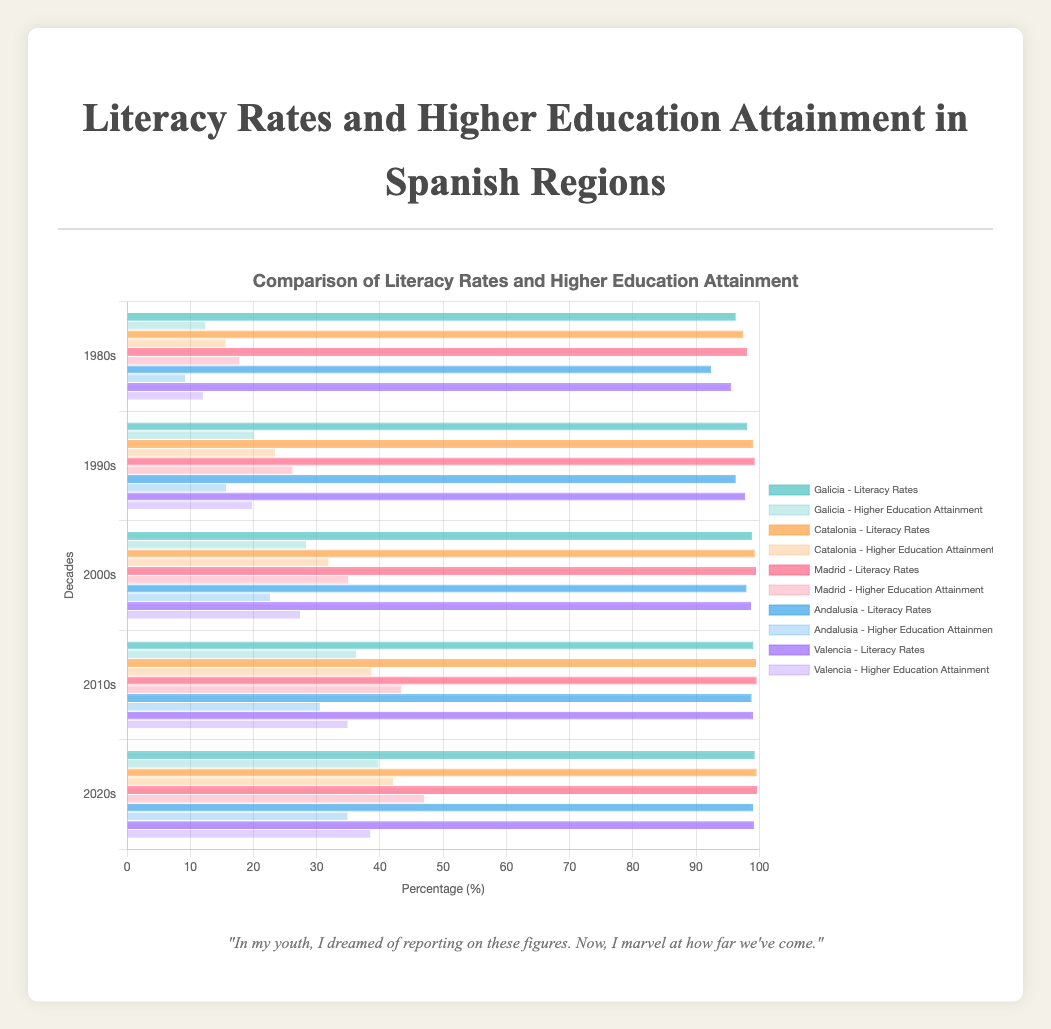Which region had the highest literacy rate in the 2020s? By observing the bar lengths for literacy rates in the 2020s, Madrid has the longest bar, indicating the highest literacy rate.
Answer: Madrid What is the difference in higher education attainment between Galicia and Madrid in the 2010s? To find the difference, subtract Galicia's higher education rate in the 2010s (36.2) from Madrid's (43.4). Thus, 43.4 - 36.2 = 7.2%.
Answer: 7.2% By how much did Galicia's literacy rate improve from the 1980s to the 2020s? Subtract the literacy rate of Galicia in the 1980s (96.3) from its rate in the 2020s (99.3). Thus, 99.3 - 96.3 = 3%.
Answer: 3% Which region showed the biggest increase in higher education attainment from the 1980s to the 2020s? Calculate the difference for each region: Galicia (39.8 - 12.4 = 27.4), Catalonia (42.1 - 15.6 = 26.5), Madrid (47.0 - 17.8 = 29.2), Andalusia (34.9 - 9.2 = 25.7), and Valencia (38.5 - 12.0 = 26.5). Madrid has the highest increase.
Answer: Madrid What was the average literacy rate for Galicia across all the decades? Add the literacy rates for Galicia across the decades and divide by the number of decades: (96.3 + 98.1 + 98.9 + 99.1 + 99.3) / 5 = 98.34%.
Answer: 98.34% Which decade had the lowest higher education attainment for Catalonia? Compare the heights of the higher education bars for Catalonia across all decades. The 1980s has the shortest bar and thus the lowest rate.
Answer: 1980s Did Andalusia ever surpass a literacy rate of 99% in any decade? Observe the literacy rate bars for Andalusia in all decades. The highest bar is in the 2020s at 99.0%, not surpassing 99%.
Answer: No By how much did Valencia's higher education attainment rate increase from the 1990s to the 2000s? Subtract Valencia's higher education rate in the 1990s (19.8) from its rate in the 2000s (27.4). Thus, 27.4 - 19.8 = 7.6%.
Answer: 7.6% What color represents literacy rates in Galicia on the chart? The visual attribute for Galicia's literacy rate bars is described by the first color in the datasets, which is a variant of 'turquoise blue'.
Answer: Turquoise blue Which region had the lowest literacy rate in the 1980s and what was it? Observe the literacy rate bars for all regions in the 1980s. Andalusia has the shortest bar with a literacy rate of 92.4%.
Answer: Andalusia, 92.4% 